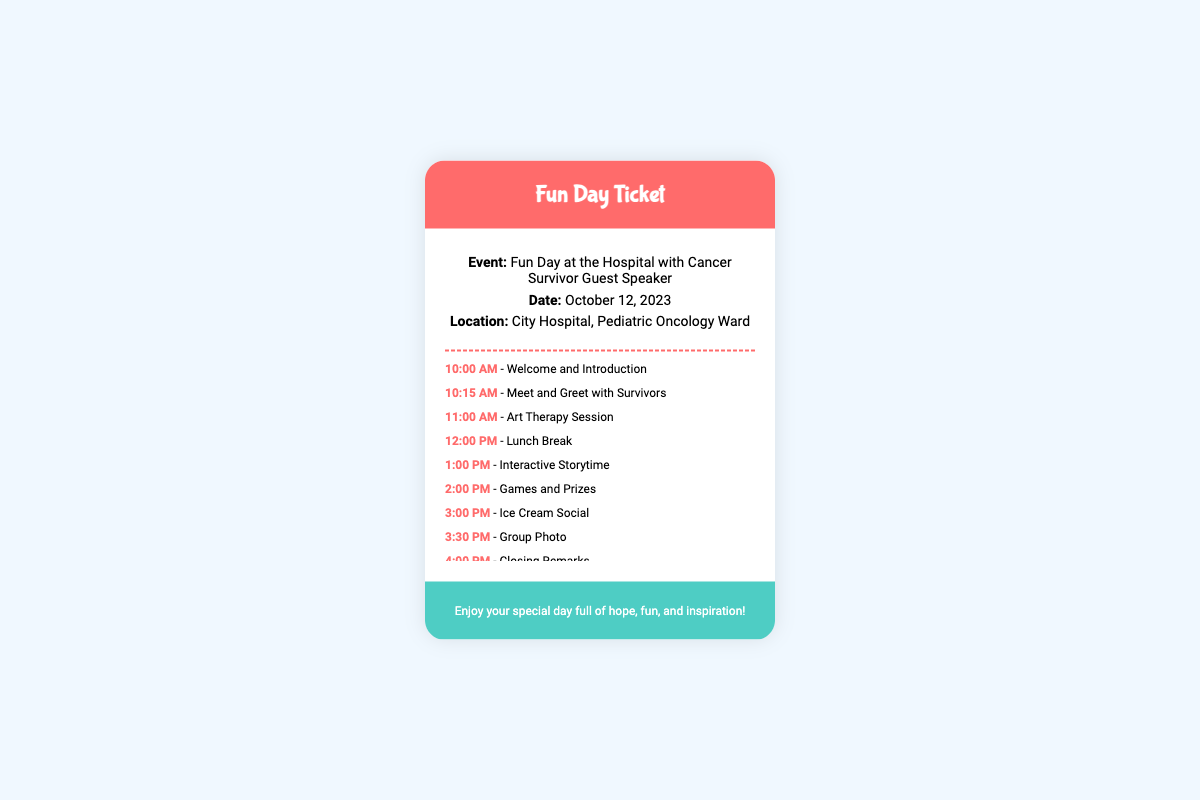What is the event title? The title of the event is clearly stated in the document as "Fun Day at the Hospital with Cancer Survivor Guest Speaker."
Answer: Fun Day at the Hospital with Cancer Survivor Guest Speaker What is the date of the event? The document specifies the date of the event, which is mentioned directly.
Answer: October 12, 2023 Where is the event taking place? The location is provided in the document and mentions the specific place for the event.
Answer: City Hospital, Pediatric Oncology Ward What activity starts at noon? The lunch break is listed in the activities, specifying its time.
Answer: Lunch Break How many activities are listed in total? By counting the activities provided, we can determine the total number of activities in the document.
Answer: 9 What is the last activity listed? The document concludes with the final activity, which is stated at the end of the activities section.
Answer: Closing Remarks What time does the Ice Cream Social start? The starting time for the Ice Cream Social is specifically detailed in the schedule of activities.
Answer: 3:00 PM What color is the ticket header? The color of the ticket header is mentioned, highlighting its visual details.
Answer: Pink What kind of special day does the footer wish for the attendees? The footer expresses a hopeful sentiment for the attendees about the nature of the day.
Answer: Hope, fun, and inspiration 